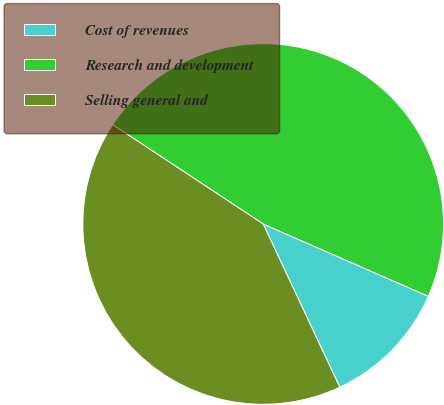<chart> <loc_0><loc_0><loc_500><loc_500><pie_chart><fcel>Cost of revenues<fcel>Research and development<fcel>Selling general and<nl><fcel>11.45%<fcel>47.29%<fcel>41.27%<nl></chart> 